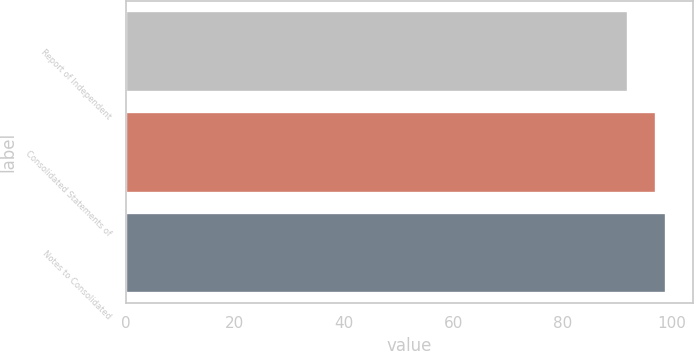Convert chart to OTSL. <chart><loc_0><loc_0><loc_500><loc_500><bar_chart><fcel>Report of Independent<fcel>Consolidated Statements of<fcel>Notes to Consolidated<nl><fcel>92<fcel>97<fcel>99<nl></chart> 